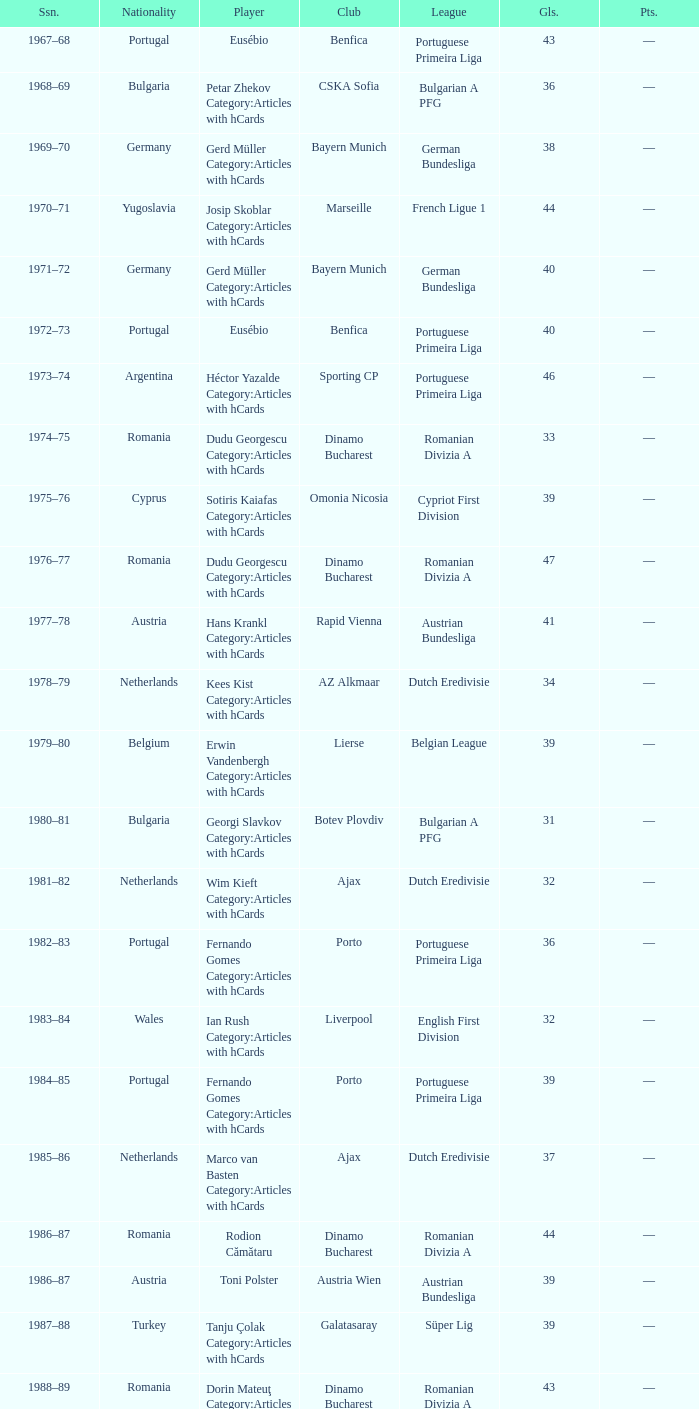Which league's nationality was Italy when there were 62 points? Italian Serie A. 